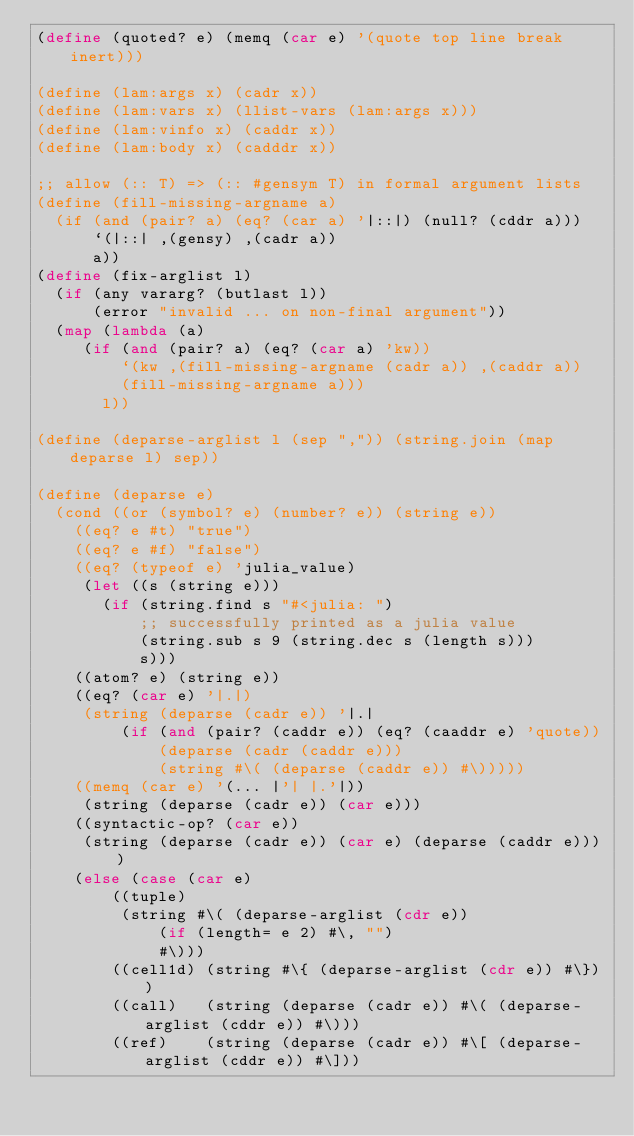Convert code to text. <code><loc_0><loc_0><loc_500><loc_500><_Scheme_>(define (quoted? e) (memq (car e) '(quote top line break inert)))

(define (lam:args x) (cadr x))
(define (lam:vars x) (llist-vars (lam:args x)))
(define (lam:vinfo x) (caddr x))
(define (lam:body x) (cadddr x))

;; allow (:: T) => (:: #gensym T) in formal argument lists
(define (fill-missing-argname a)
  (if (and (pair? a) (eq? (car a) '|::|) (null? (cddr a)))
      `(|::| ,(gensy) ,(cadr a))
      a))
(define (fix-arglist l)
  (if (any vararg? (butlast l))
      (error "invalid ... on non-final argument"))
  (map (lambda (a)
	 (if (and (pair? a) (eq? (car a) 'kw))
	     `(kw ,(fill-missing-argname (cadr a)) ,(caddr a))
	     (fill-missing-argname a)))
       l))

(define (deparse-arglist l (sep ",")) (string.join (map deparse l) sep))

(define (deparse e)
  (cond ((or (symbol? e) (number? e)) (string e))
	((eq? e #t) "true")
	((eq? e #f) "false")
	((eq? (typeof e) 'julia_value)
	 (let ((s (string e)))
	   (if (string.find s "#<julia: ")
	       ;; successfully printed as a julia value
	       (string.sub s 9 (string.dec s (length s)))
	       s)))
	((atom? e) (string e))
	((eq? (car e) '|.|)
	 (string (deparse (cadr e)) '|.|
		 (if (and (pair? (caddr e)) (eq? (caaddr e) 'quote))
		     (deparse (cadr (caddr e)))
		     (string #\( (deparse (caddr e)) #\)))))
	((memq (car e) '(... |'| |.'|))
	 (string (deparse (cadr e)) (car e)))
	((syntactic-op? (car e))
	 (string (deparse (cadr e)) (car e) (deparse (caddr e))))
	(else (case (car e)
		((tuple)
		 (string #\( (deparse-arglist (cdr e))
			 (if (length= e 2) #\, "")
			 #\)))
		((cell1d) (string #\{ (deparse-arglist (cdr e)) #\}))
		((call)   (string (deparse (cadr e)) #\( (deparse-arglist (cddr e)) #\)))
		((ref)    (string (deparse (cadr e)) #\[ (deparse-arglist (cddr e)) #\]))</code> 